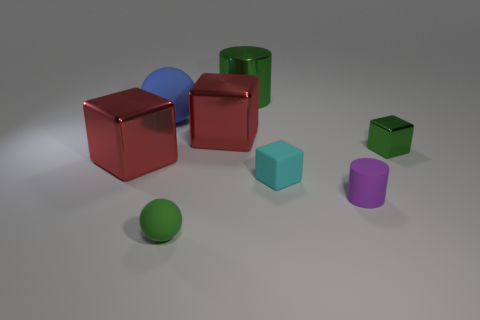Subtract all green shiny blocks. How many blocks are left? 3 Subtract all green blocks. How many blocks are left? 3 Subtract all blue blocks. Subtract all purple spheres. How many blocks are left? 4 Add 2 matte cubes. How many objects exist? 10 Subtract all cylinders. How many objects are left? 6 Add 7 small purple matte cylinders. How many small purple matte cylinders exist? 8 Subtract 0 gray cylinders. How many objects are left? 8 Subtract all small red rubber balls. Subtract all small green matte spheres. How many objects are left? 7 Add 1 big blue rubber objects. How many big blue rubber objects are left? 2 